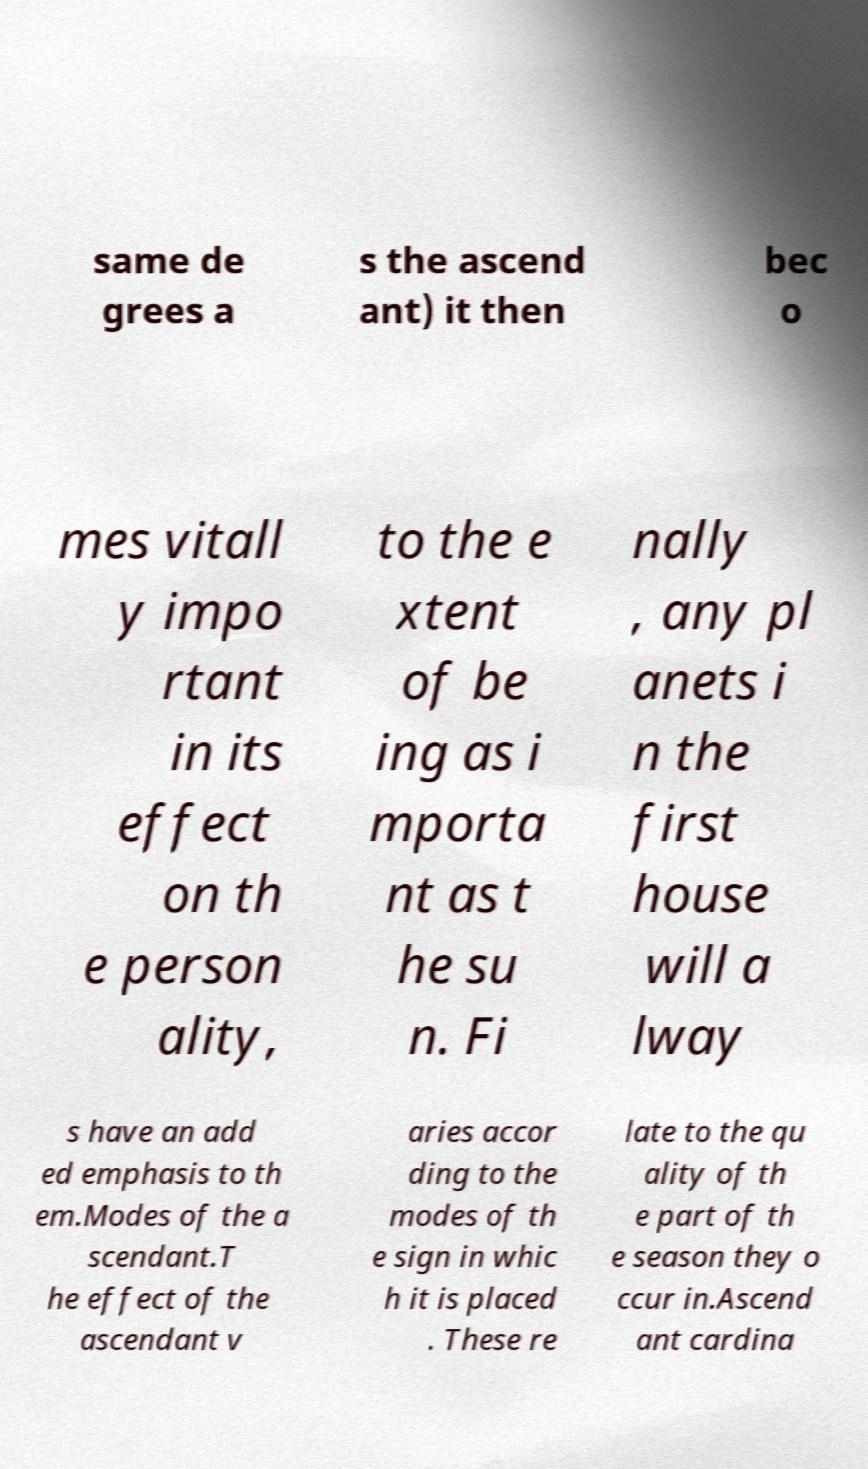For documentation purposes, I need the text within this image transcribed. Could you provide that? same de grees a s the ascend ant) it then bec o mes vitall y impo rtant in its effect on th e person ality, to the e xtent of be ing as i mporta nt as t he su n. Fi nally , any pl anets i n the first house will a lway s have an add ed emphasis to th em.Modes of the a scendant.T he effect of the ascendant v aries accor ding to the modes of th e sign in whic h it is placed . These re late to the qu ality of th e part of th e season they o ccur in.Ascend ant cardina 